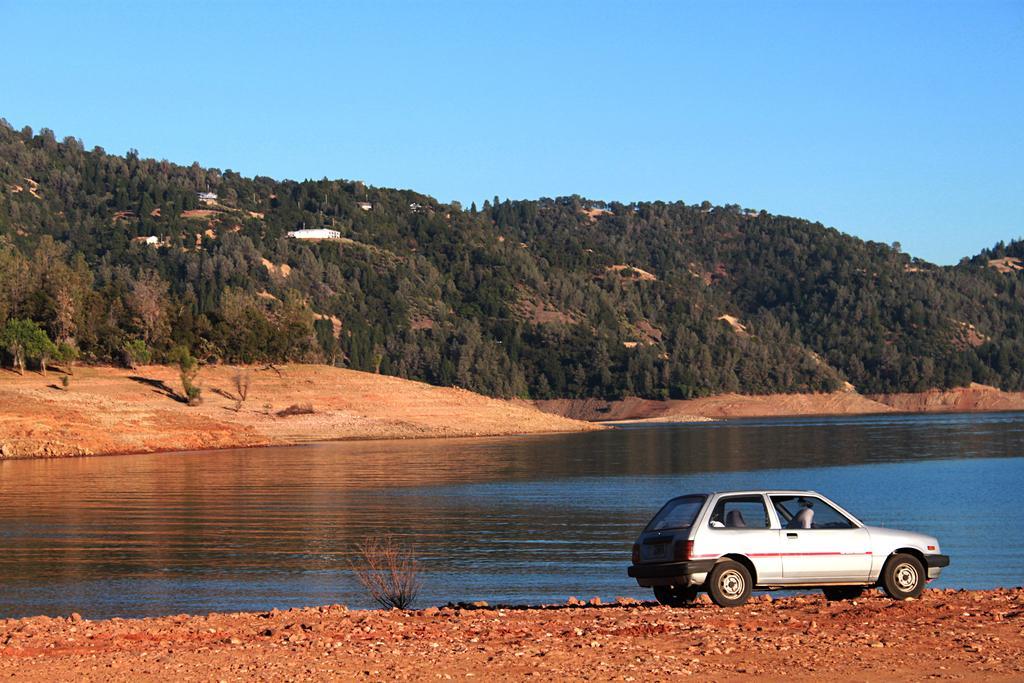Can you describe this image briefly? At the bottom of the image there is a vehicle. Behind the vehicle there is water. In the middle of the image there are some trees and hills. At the top of the image there is sky. 